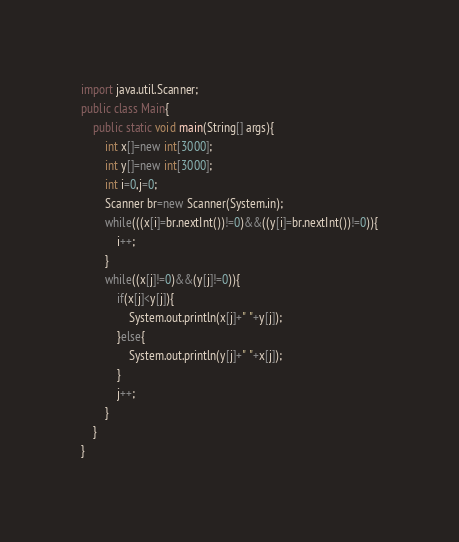Convert code to text. <code><loc_0><loc_0><loc_500><loc_500><_Java_>import java.util.Scanner;
public class Main{
	public static void main(String[] args){
		int x[]=new int[3000];
		int y[]=new int[3000];
		int i=0,j=0;
		Scanner br=new Scanner(System.in);
		while(((x[i]=br.nextInt())!=0)&&((y[i]=br.nextInt())!=0)){
			i++;
		}
		while((x[j]!=0)&&(y[j]!=0)){
			if(x[j]<y[j]){
				System.out.println(x[j]+" "+y[j]);
			}else{
				System.out.println(y[j]+" "+x[j]);
			}
			j++;
		}
	}
}</code> 